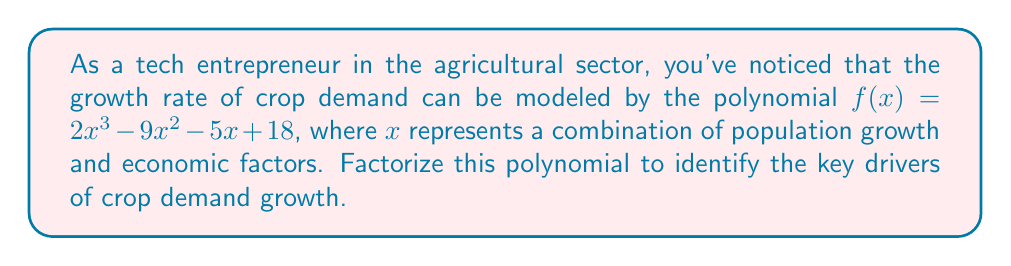Could you help me with this problem? Let's factorize the polynomial $f(x) = 2x^3 - 9x^2 - 5x + 18$ step by step:

1) First, let's check if there's a common factor:
   There's no common factor for all terms, so we proceed to the next step.

2) We can try to guess one factor by finding the factors of the constant term (18) and the leading coefficient (2):
   Factors of 18: ±1, ±2, ±3, ±6, ±9, ±18
   Factors of 2: ±1, ±2

   Testing these values, we find that $f(3) = 0$, so $(x - 3)$ is a factor.

3) Divide $f(x)$ by $(x - 3)$ using polynomial long division:

   $$
   \begin{array}{r}
   2x^2 + 3x + 4 \\
   x - 3 \enclose{longdiv}{2x^3 - 9x^2 - 5x + 18} \\
   \underline{2x^3 - 6x^2} \\
   -3x^2 - 5x \\
   \underline{-3x^2 + 9x} \\
   4x + 18 \\
   \underline{4x - 12} \\
   30
   \end{array}
   $$

   So, $f(x) = (x - 3)(2x^2 + 3x + 4)$

4) Now we need to factorize $2x^2 + 3x + 4$. Let's use the quadratic formula:
   $ax^2 + bx + c = 0$
   $x = \frac{-b \pm \sqrt{b^2 - 4ac}}{2a}$

   Here, $a=2$, $b=3$, and $c=4$

   $x = \frac{-3 \pm \sqrt{3^2 - 4(2)(4)}}{2(2)}$
   $= \frac{-3 \pm \sqrt{9 - 32}}{4}$
   $= \frac{-3 \pm \sqrt{-23}}{4}$

   Since the discriminant is negative, there are no real roots. This quadratic cannot be factored further over the real numbers.

5) Therefore, the final factorization is:
   $f(x) = (x - 3)(2x^2 + 3x + 4)$

This factorization shows that one key driver of crop demand growth occurs when the combination of population and economic factors (x) equals 3, and the other drivers are more complex, represented by the quadratic factor.
Answer: $(x - 3)(2x^2 + 3x + 4)$ 